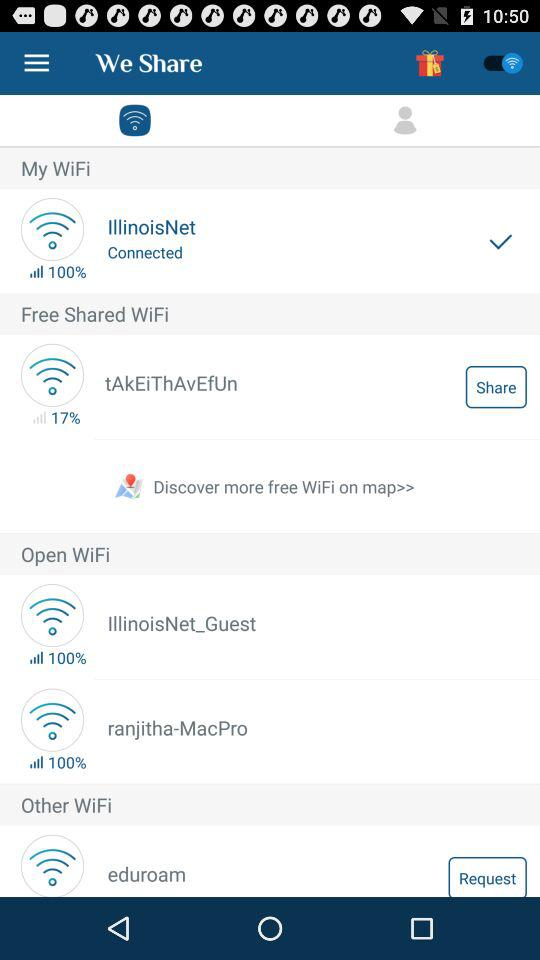How many of the WiFi networks are not IllinoisNet?
Answer the question using a single word or phrase. 3 